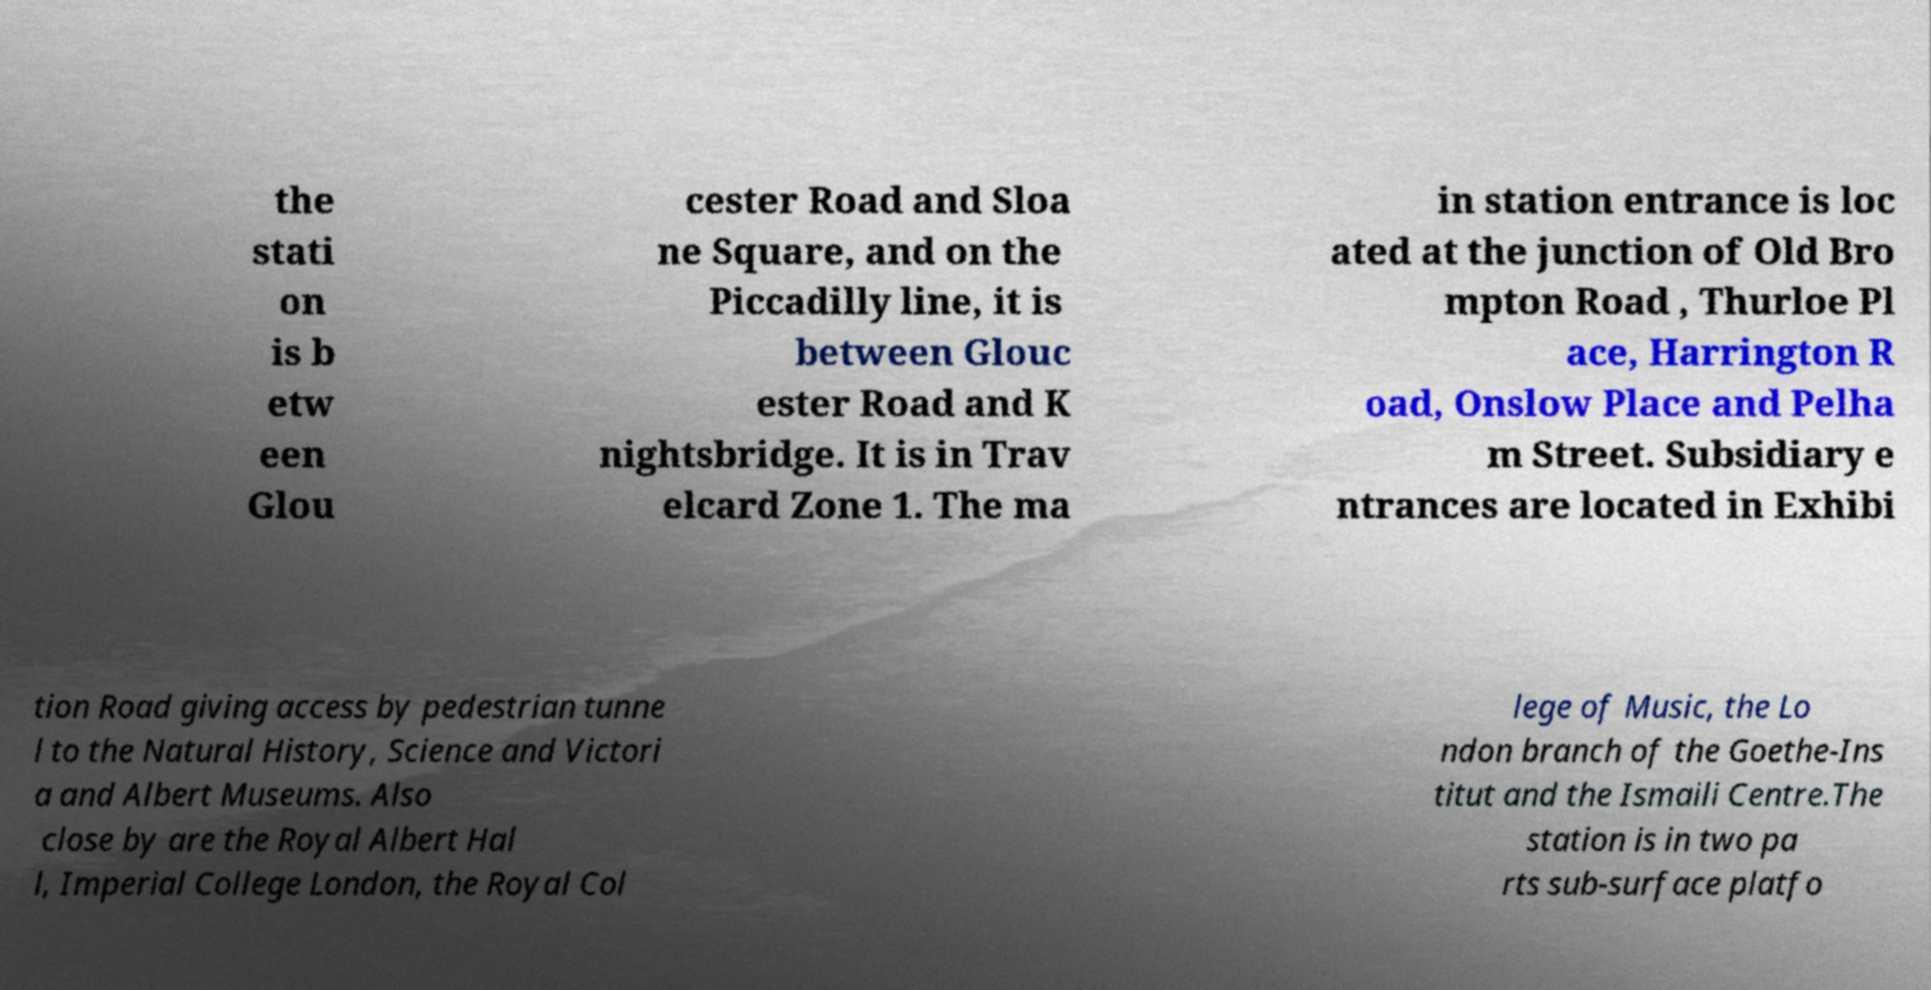For documentation purposes, I need the text within this image transcribed. Could you provide that? the stati on is b etw een Glou cester Road and Sloa ne Square, and on the Piccadilly line, it is between Glouc ester Road and K nightsbridge. It is in Trav elcard Zone 1. The ma in station entrance is loc ated at the junction of Old Bro mpton Road , Thurloe Pl ace, Harrington R oad, Onslow Place and Pelha m Street. Subsidiary e ntrances are located in Exhibi tion Road giving access by pedestrian tunne l to the Natural History, Science and Victori a and Albert Museums. Also close by are the Royal Albert Hal l, Imperial College London, the Royal Col lege of Music, the Lo ndon branch of the Goethe-Ins titut and the Ismaili Centre.The station is in two pa rts sub-surface platfo 